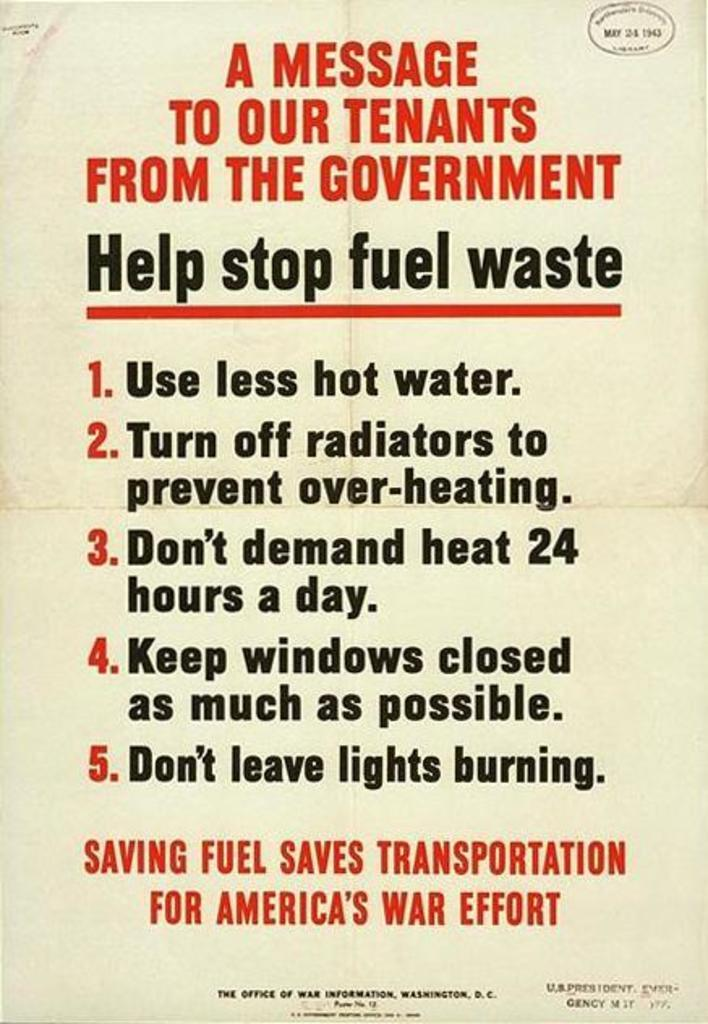<image>
Render a clear and concise summary of the photo. An appeal poster in Red and black from American government to save fuel 